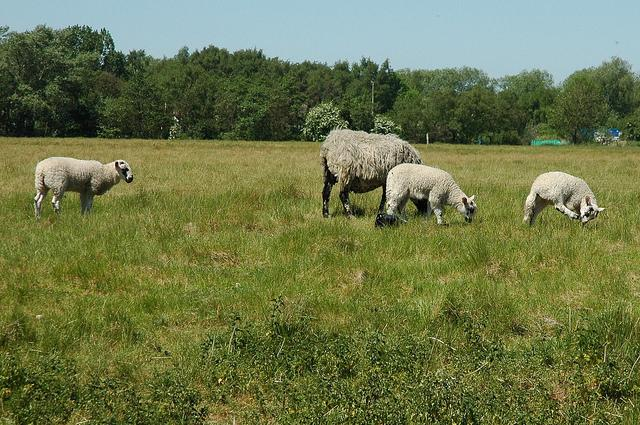What meal would these animals prefer? Please explain your reasoning. salad. The meal is a salad. 